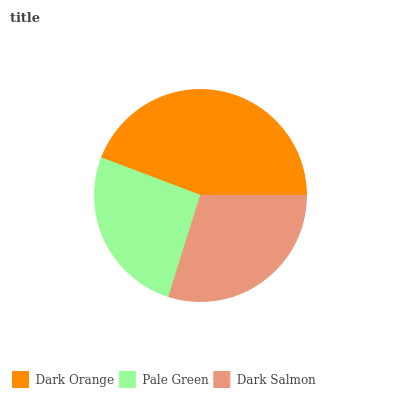Is Pale Green the minimum?
Answer yes or no. Yes. Is Dark Orange the maximum?
Answer yes or no. Yes. Is Dark Salmon the minimum?
Answer yes or no. No. Is Dark Salmon the maximum?
Answer yes or no. No. Is Dark Salmon greater than Pale Green?
Answer yes or no. Yes. Is Pale Green less than Dark Salmon?
Answer yes or no. Yes. Is Pale Green greater than Dark Salmon?
Answer yes or no. No. Is Dark Salmon less than Pale Green?
Answer yes or no. No. Is Dark Salmon the high median?
Answer yes or no. Yes. Is Dark Salmon the low median?
Answer yes or no. Yes. Is Pale Green the high median?
Answer yes or no. No. Is Dark Orange the low median?
Answer yes or no. No. 